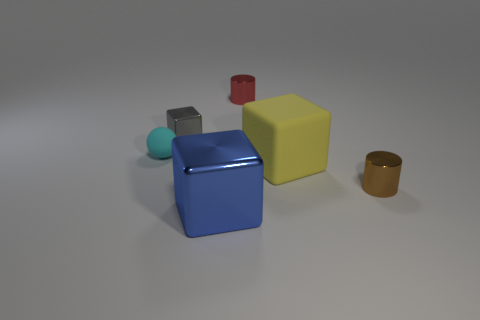What number of cylinders are there?
Your answer should be compact. 2. How many tiny rubber objects are behind the cyan thing?
Give a very brief answer. 0. Is the gray cube made of the same material as the yellow cube?
Provide a succinct answer. No. How many tiny objects are both right of the red thing and to the left of the yellow cube?
Provide a succinct answer. 0. How many yellow objects are either large metal cubes or large objects?
Make the answer very short. 1. What is the size of the ball?
Your answer should be very brief. Small. What number of matte objects are either gray things or red cylinders?
Ensure brevity in your answer.  0. Are there fewer tiny cyan cubes than things?
Make the answer very short. Yes. What number of other things are there of the same material as the yellow cube
Provide a succinct answer. 1. What size is the blue object that is the same shape as the big yellow matte thing?
Your answer should be compact. Large. 